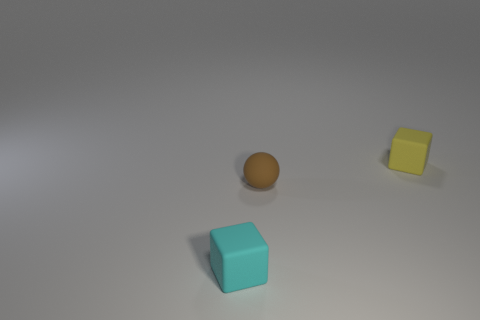Add 2 yellow rubber things. How many objects exist? 5 Subtract all spheres. How many objects are left? 2 Add 1 yellow cubes. How many yellow cubes exist? 2 Subtract 0 brown cylinders. How many objects are left? 3 Subtract all small brown matte things. Subtract all cyan matte blocks. How many objects are left? 1 Add 2 tiny blocks. How many tiny blocks are left? 4 